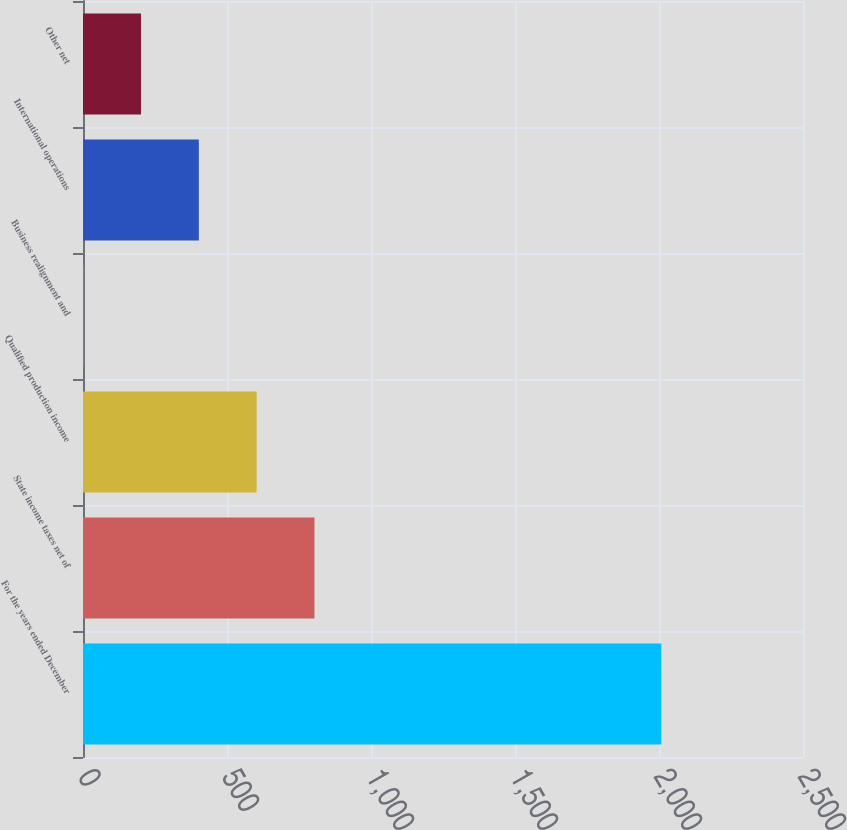<chart> <loc_0><loc_0><loc_500><loc_500><bar_chart><fcel>For the years ended December<fcel>State income taxes net of<fcel>Qualified production income<fcel>Business realignment and<fcel>International operations<fcel>Other net<nl><fcel>2008<fcel>803.62<fcel>602.89<fcel>0.7<fcel>402.16<fcel>201.43<nl></chart> 